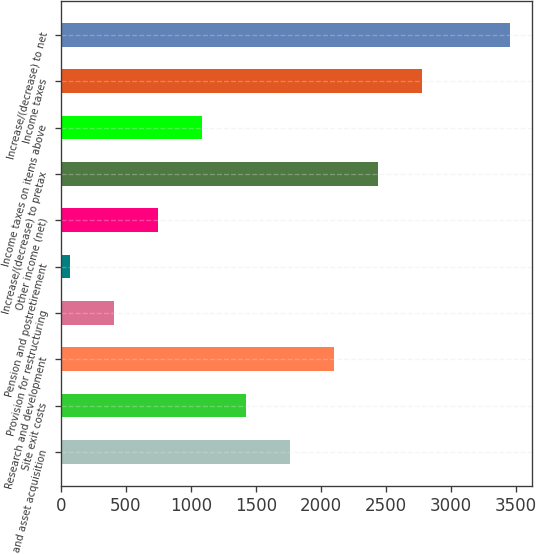<chart> <loc_0><loc_0><loc_500><loc_500><bar_chart><fcel>License and asset acquisition<fcel>Site exit costs<fcel>Research and development<fcel>Provision for restructuring<fcel>Pension and postretirement<fcel>Other income (net)<fcel>Increase/(decrease) to pretax<fcel>Income taxes on items above<fcel>Income taxes<fcel>Increase/(decrease) to net<nl><fcel>1761<fcel>1423<fcel>2099<fcel>409<fcel>71<fcel>747<fcel>2437<fcel>1085<fcel>2775<fcel>3451<nl></chart> 